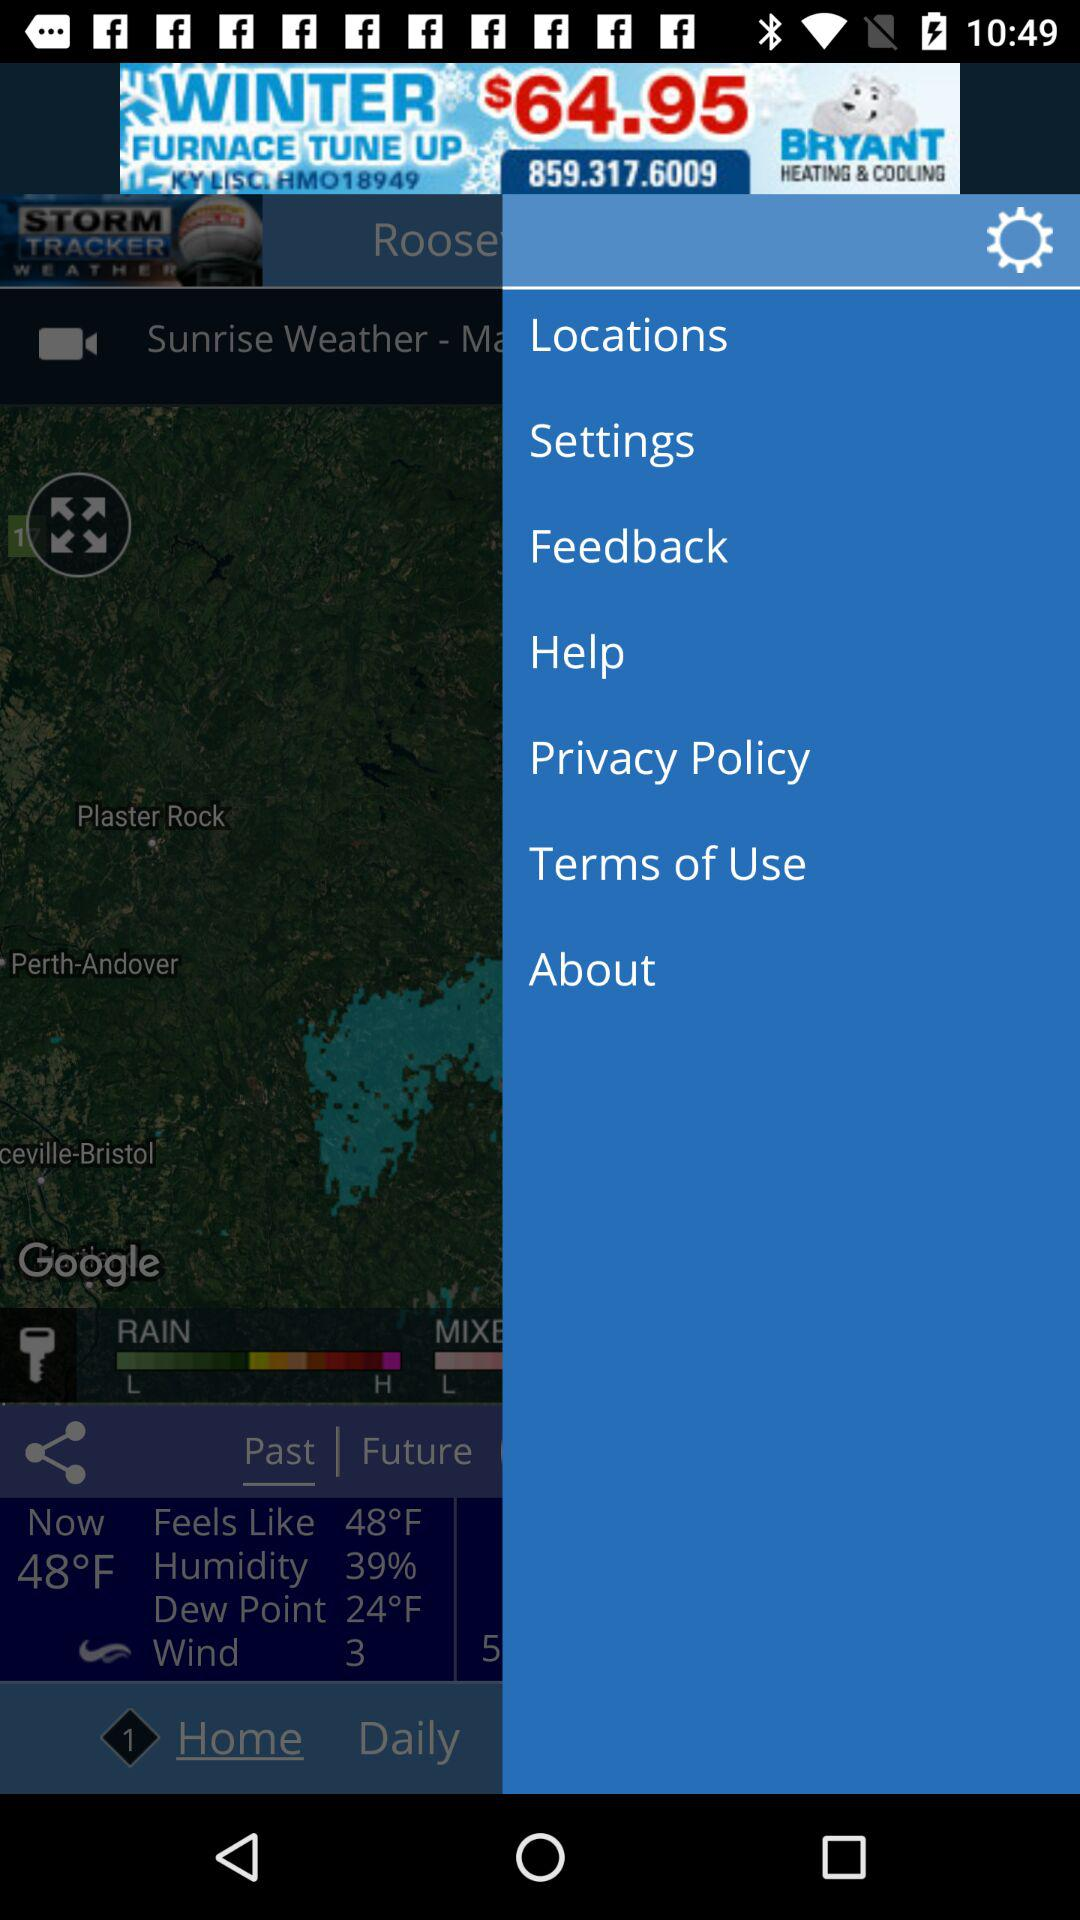What does the color turquoise on the radar image represent? The turquoise color on the radar image generally indicates light precipitation. It is likely showing regions where there's either light rain or snow, depending on the local temperatures. Radar images use color coding to represent the intensity of precipitation, with lighter colors for less severe weather and darker colors for more intense conditions. 